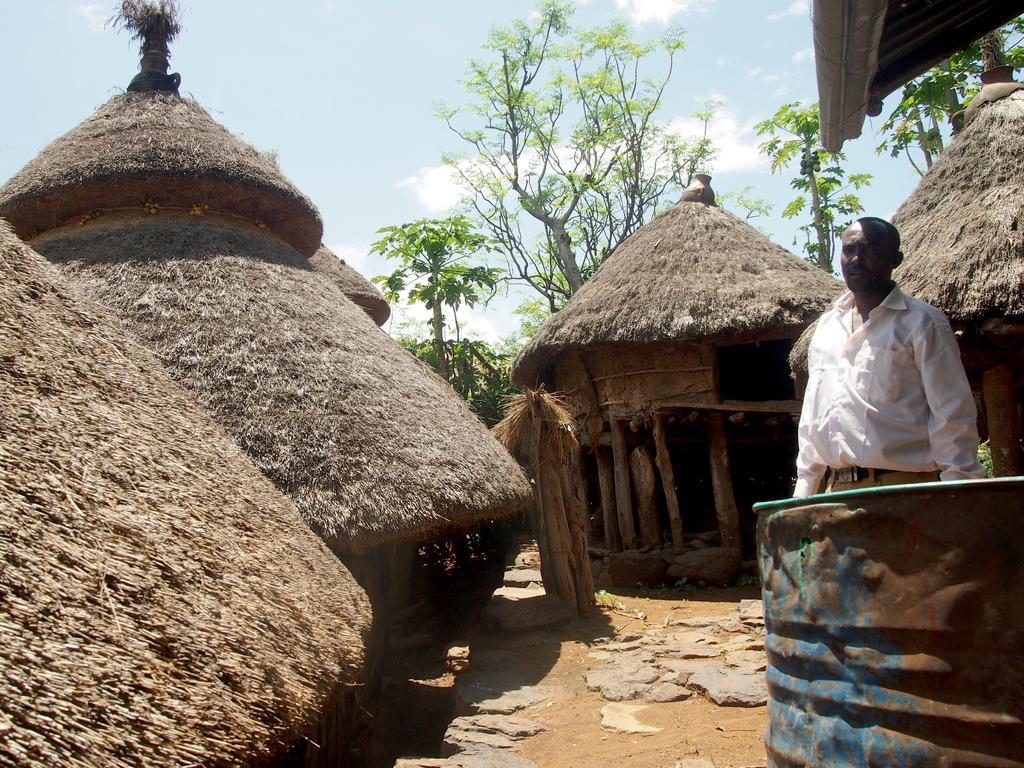How would you summarize this image in a sentence or two? In the image there are small huts and there is a man standing on the right side, in the background there are trees. 